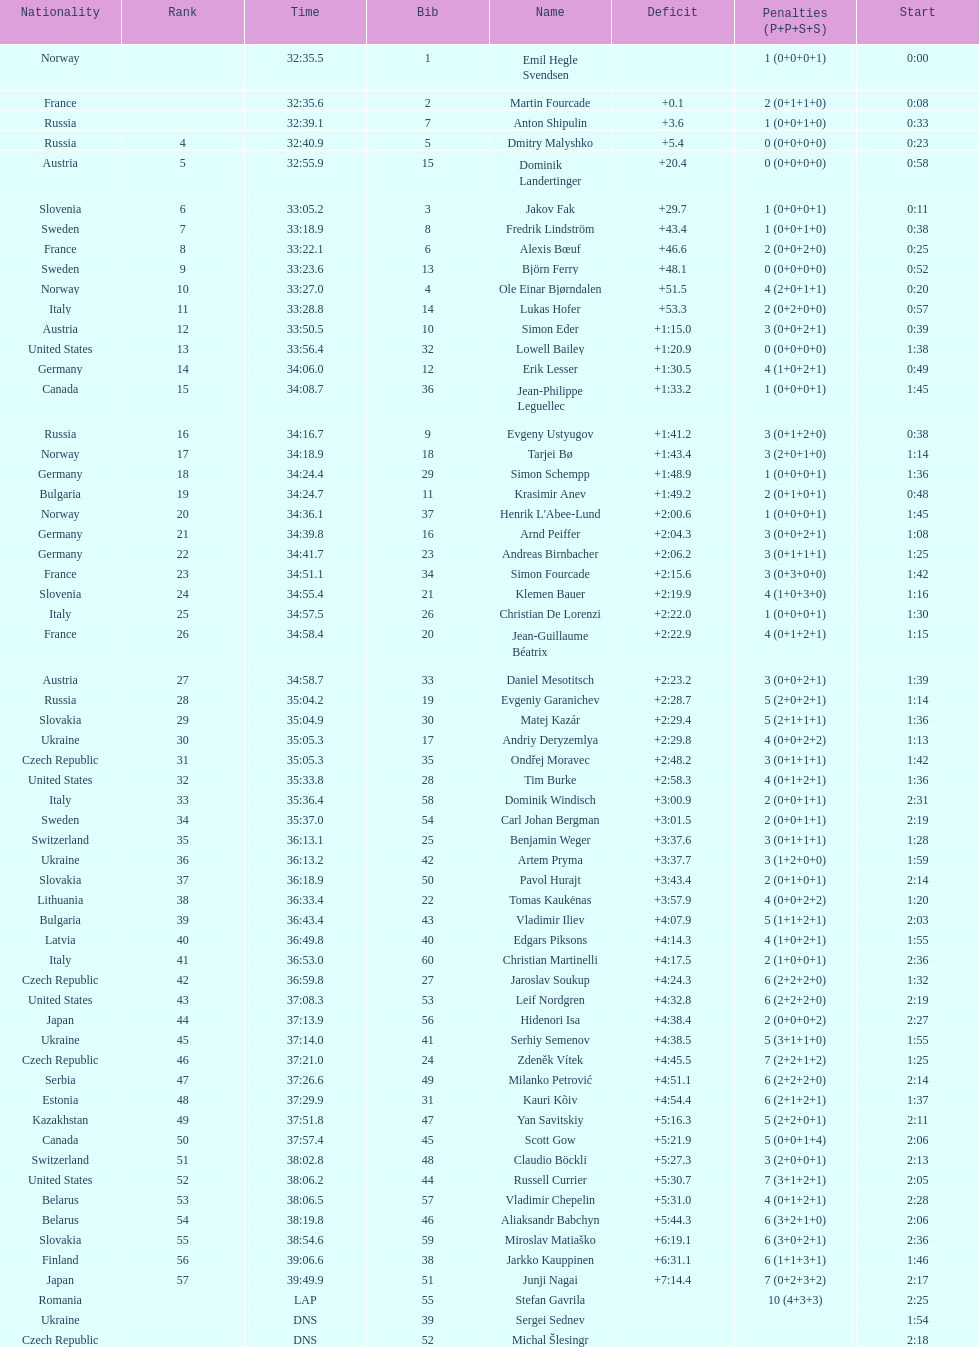How many penalties did germany get all together? 11. 